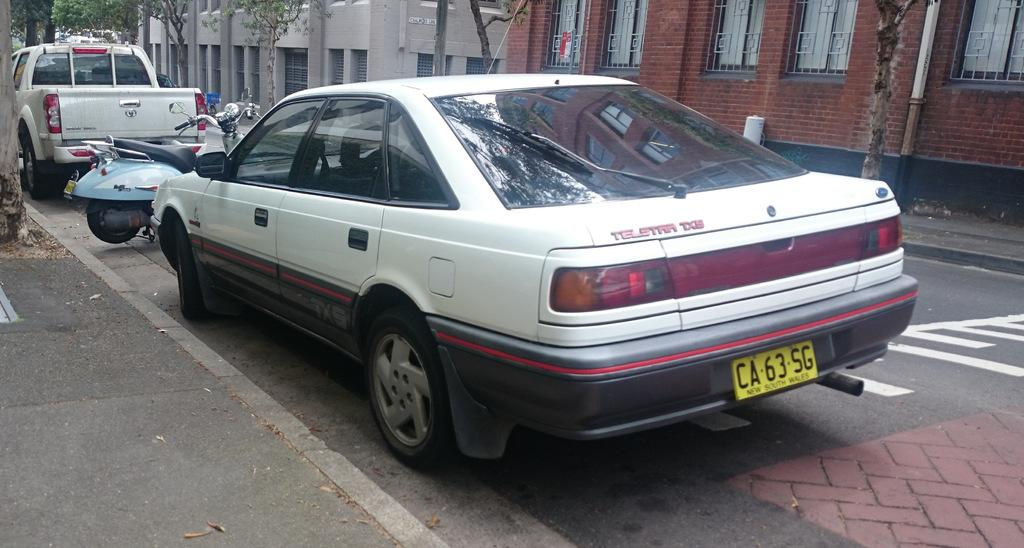What can be seen parked on the side of the road in the image? There are vehicles parked on the side of the road in the image. What type of trees are present in the image? There are trees with visible bark in the image. Can you describe the trees in the image? There are trees present in the image. What is located in the image besides the trees? There is a pole and a signboard in the image. What type of structures can be seen in the image? There are buildings with windows in the image. What type of knife is being used to play the guitar in the image? There is no knife or guitar present in the image. How many tickets can be seen on the pole in the image? There are no tickets present on the pole in the image. 